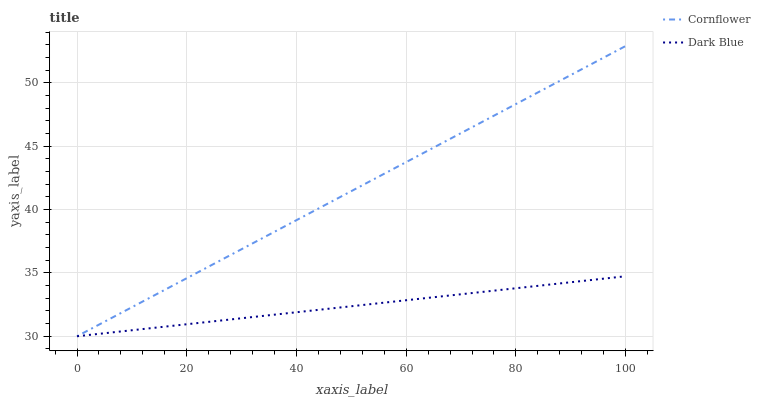Does Dark Blue have the minimum area under the curve?
Answer yes or no. Yes. Does Cornflower have the maximum area under the curve?
Answer yes or no. Yes. Does Dark Blue have the maximum area under the curve?
Answer yes or no. No. Is Dark Blue the smoothest?
Answer yes or no. Yes. Is Cornflower the roughest?
Answer yes or no. Yes. Is Dark Blue the roughest?
Answer yes or no. No. Does Dark Blue have the highest value?
Answer yes or no. No. 